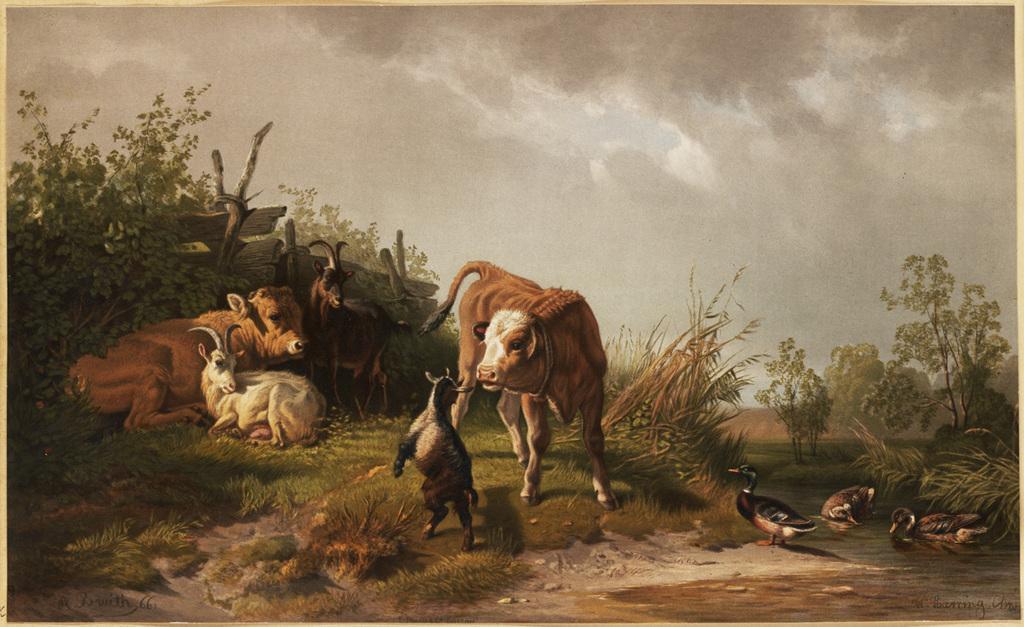Please provide a concise description of this image. In this image I can see few animals. They are in brown,black and white color. I can see few ducks,trees,grass and wooden logs. The sky is in white and ash color. 